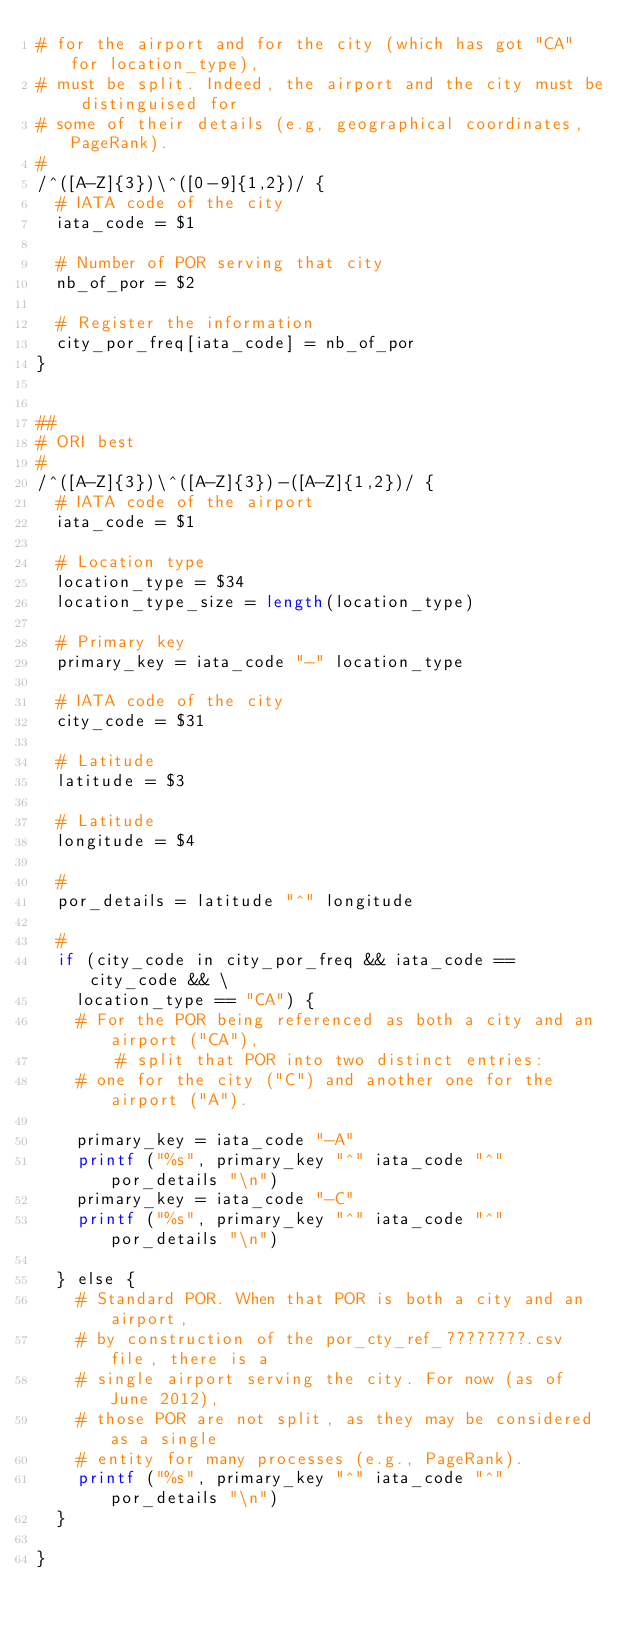<code> <loc_0><loc_0><loc_500><loc_500><_Awk_># for the airport and for the city (which has got "CA" for location_type),
# must be split. Indeed, the airport and the city must be distinguised for
# some of their details (e.g, geographical coordinates, PageRank).
#
/^([A-Z]{3})\^([0-9]{1,2})/ {
	# IATA code of the city
	iata_code = $1

	# Number of POR serving that city
	nb_of_por = $2

	# Register the information
	city_por_freq[iata_code] = nb_of_por
}


##
# ORI best
#
/^([A-Z]{3})\^([A-Z]{3})-([A-Z]{1,2})/ {
	# IATA code of the airport
	iata_code = $1

	# Location type
	location_type = $34
	location_type_size = length(location_type)

	# Primary key
	primary_key = iata_code "-" location_type
	
	# IATA code of the city
	city_code = $31

	# Latitude
	latitude = $3

	# Latitude
	longitude = $4

	#
	por_details = latitude "^" longitude

	#
	if (city_code in city_por_freq && iata_code == city_code && \
		location_type == "CA") {
		# For the POR being referenced as both a city and an airport ("CA"),
        # split that POR into two distinct entries:
		# one for the city ("C") and another one for the airport ("A").

		primary_key = iata_code "-A"
		printf ("%s", primary_key "^" iata_code "^" por_details "\n")
		primary_key = iata_code "-C"
		printf ("%s", primary_key "^" iata_code "^" por_details "\n")

	} else {
		# Standard POR. When that POR is both a city and an airport,
		# by construction of the por_cty_ref_????????.csv file, there is a
		# single airport serving the city. For now (as of June 2012),
		# those POR are not split, as they may be considered as a single
		# entity for many processes (e.g., PageRank).
		printf ("%s", primary_key "^" iata_code "^" por_details "\n")
	}

}
</code> 